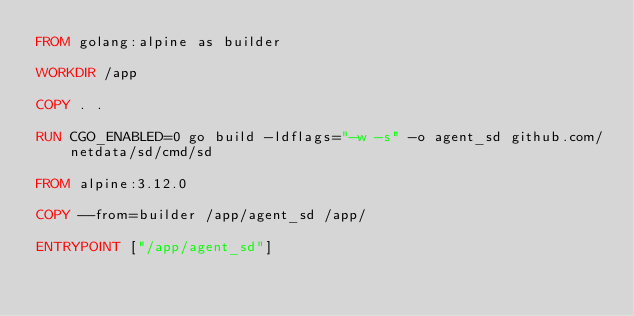Convert code to text. <code><loc_0><loc_0><loc_500><loc_500><_Dockerfile_>FROM golang:alpine as builder

WORKDIR /app

COPY . .

RUN CGO_ENABLED=0 go build -ldflags="-w -s" -o agent_sd github.com/netdata/sd/cmd/sd

FROM alpine:3.12.0

COPY --from=builder /app/agent_sd /app/

ENTRYPOINT ["/app/agent_sd"]
</code> 